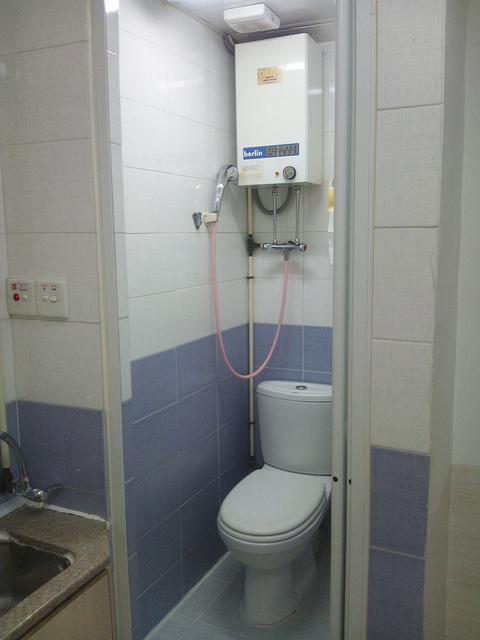Describe the objects in this image and their specific colors. I can see toilet in gray, darkgray, and black tones and sink in gray and black tones in this image. 